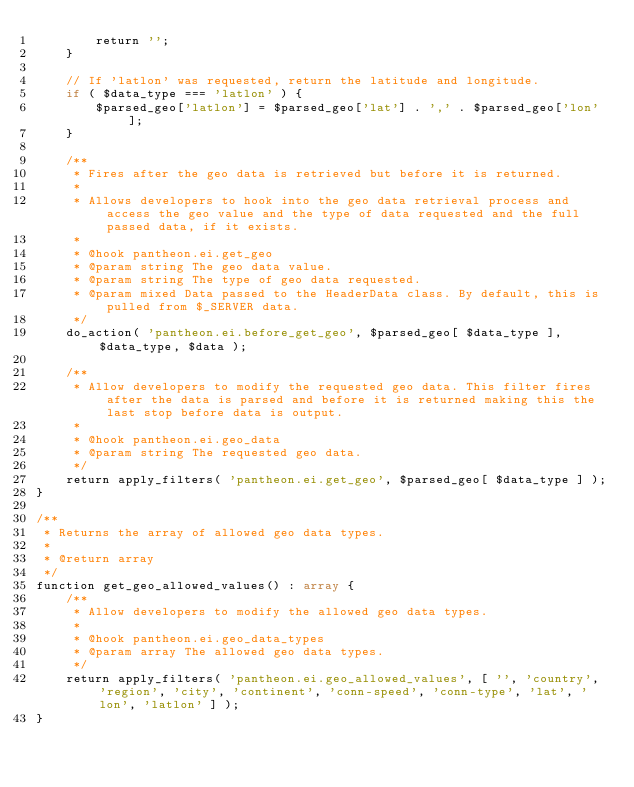<code> <loc_0><loc_0><loc_500><loc_500><_PHP_>		return '';
	}

	// If 'latlon' was requested, return the latitude and longitude.
	if ( $data_type === 'latlon' ) {
		$parsed_geo['latlon'] = $parsed_geo['lat'] . ',' . $parsed_geo['lon'];
	}

	/**
	 * Fires after the geo data is retrieved but before it is returned.
	 *
	 * Allows developers to hook into the geo data retrieval process and access the geo value and the type of data requested and the full passed data, if it exists.
	 *
	 * @hook pantheon.ei.get_geo
	 * @param string The geo data value.
	 * @param string The type of geo data requested.
	 * @param mixed Data passed to the HeaderData class. By default, this is pulled from $_SERVER data.
	 */
	do_action( 'pantheon.ei.before_get_geo', $parsed_geo[ $data_type ], $data_type, $data );

	/**
	 * Allow developers to modify the requested geo data. This filter fires after the data is parsed and before it is returned making this the last stop before data is output.
	 *
	 * @hook pantheon.ei.geo_data
	 * @param string The requested geo data.
	 */
	return apply_filters( 'pantheon.ei.get_geo', $parsed_geo[ $data_type ] );
}

/**
 * Returns the array of allowed geo data types.
 *
 * @return array
 */
function get_geo_allowed_values() : array {
	/**
	 * Allow developers to modify the allowed geo data types.
	 *
	 * @hook pantheon.ei.geo_data_types
	 * @param array The allowed geo data types.
	 */
	return apply_filters( 'pantheon.ei.geo_allowed_values', [ '', 'country', 'region', 'city', 'continent', 'conn-speed', 'conn-type', 'lat', 'lon', 'latlon' ] );
}
</code> 